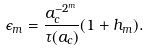Convert formula to latex. <formula><loc_0><loc_0><loc_500><loc_500>\epsilon _ { m } = \frac { a _ { c } ^ { - 2 ^ { m } } } { \tau ( a _ { c } ) } ( 1 + h _ { m } ) .</formula> 